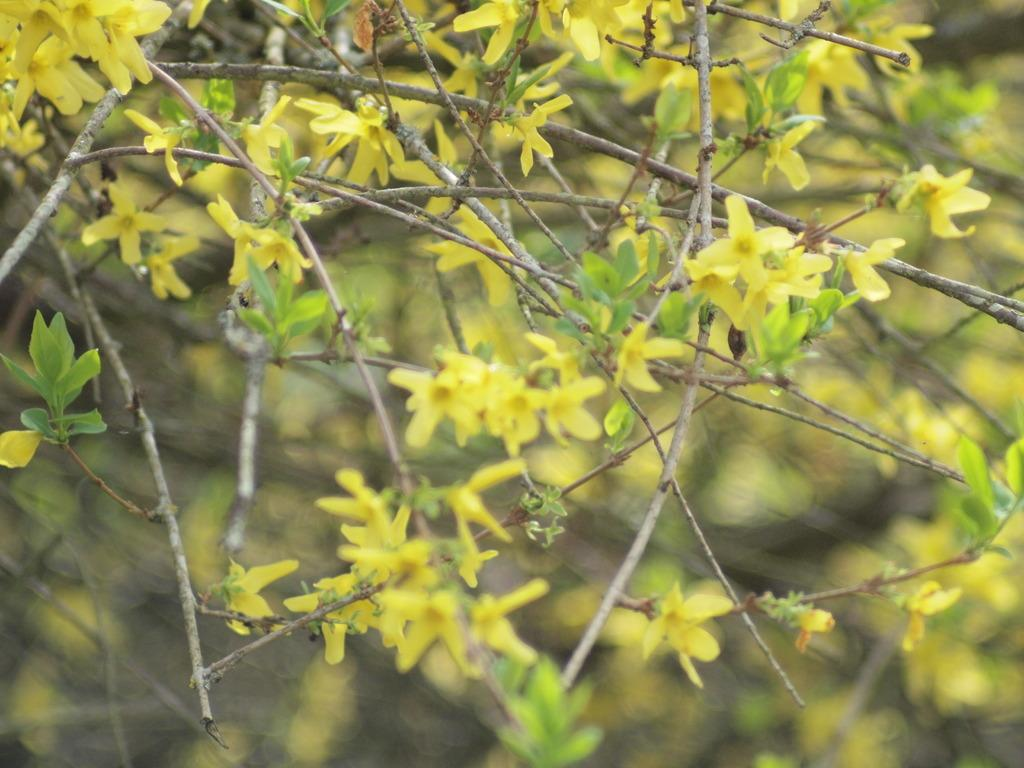What is the main subject of the image? The main subject of the image is a bunch of flowers. Where are the flowers located in the image? The flowers are on the branches of a tree. How many cherries are hanging from the brass lamp in the image? There is no brass lamp or cherries present in the image; it features a bunch of flowers on the branches of a tree. 